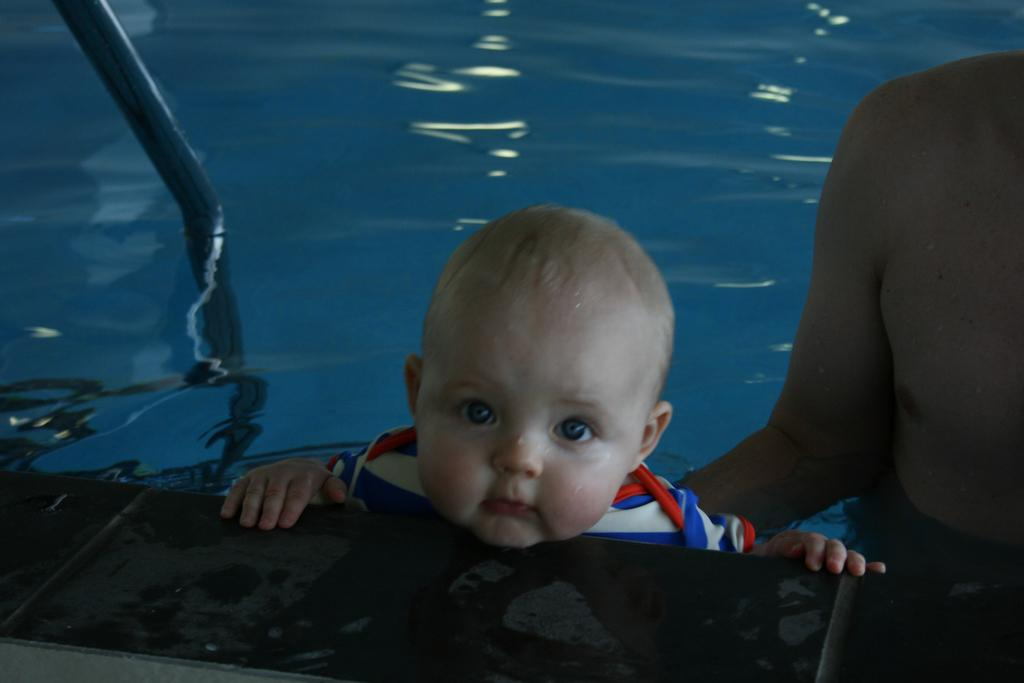How many people are in the swimming pool in the image? There are two persons in the swimming pool in the image. What object can be seen in the image besides the people in the pool? There is a metal rod in the image. What type of barrier is visible in the image? There is a fence in the image. Can you determine the time of day the image was taken? The image may have been taken during the night, as there is no visible light source. What type of ring can be seen on the finger of one of the persons in the image? There are no rings or fingers visible in the image, as the focus is on the persons in the swimming pool and the surrounding objects. 